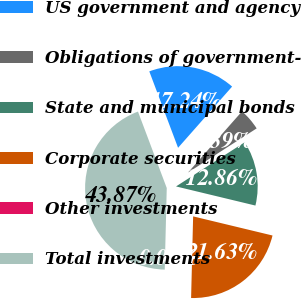Convert chart to OTSL. <chart><loc_0><loc_0><loc_500><loc_500><pie_chart><fcel>US government and agency<fcel>Obligations of government-<fcel>State and municipal bonds<fcel>Corporate securities<fcel>Other investments<fcel>Total investments<nl><fcel>17.24%<fcel>4.39%<fcel>12.86%<fcel>21.63%<fcel>0.0%<fcel>43.87%<nl></chart> 